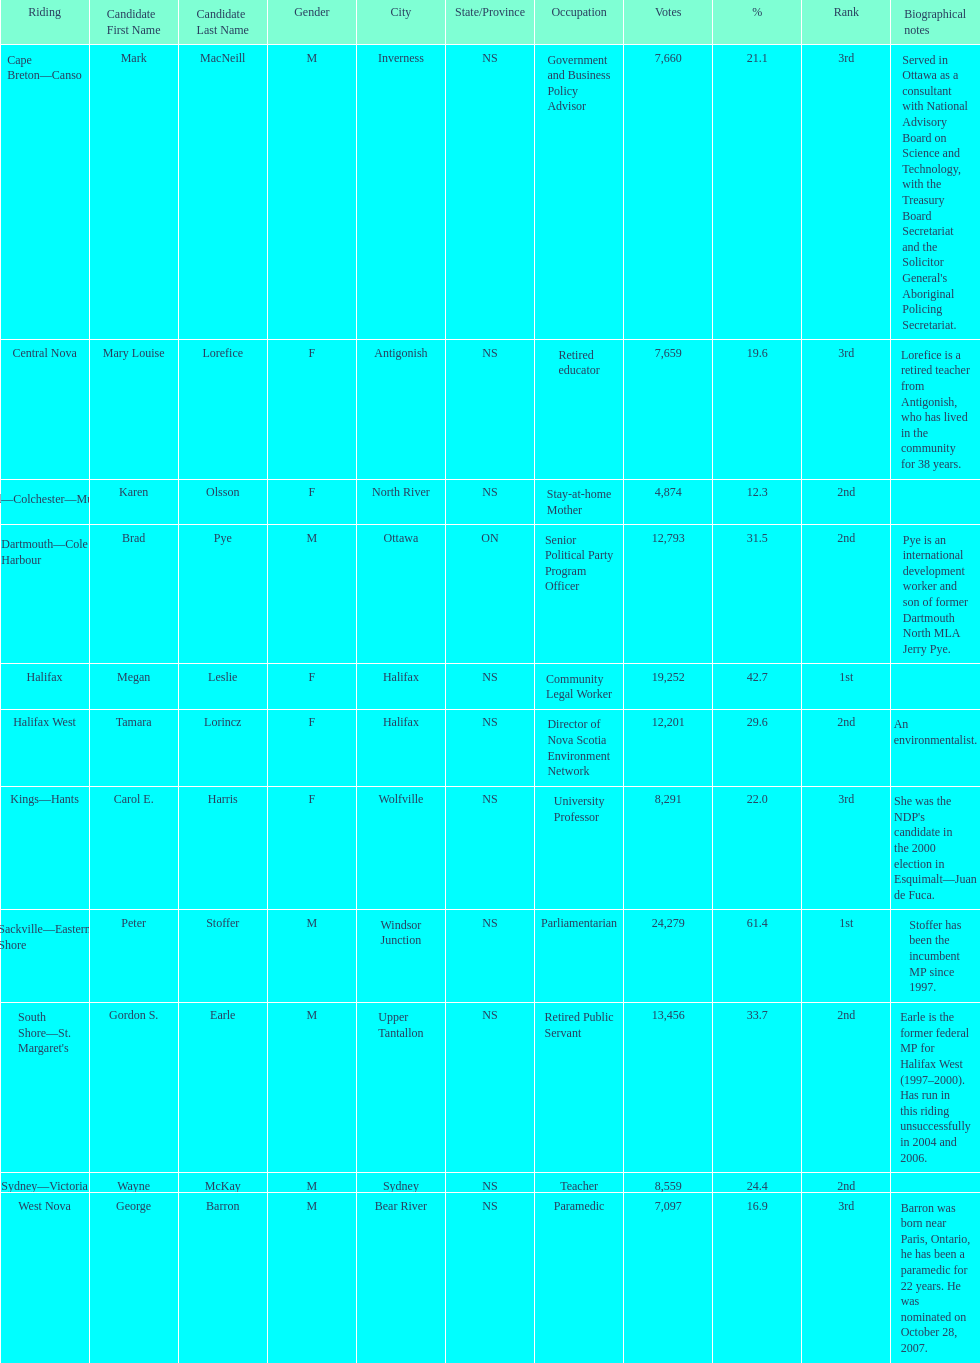Who got a larger number of votes, macneill or olsson? Mark MacNeill. 